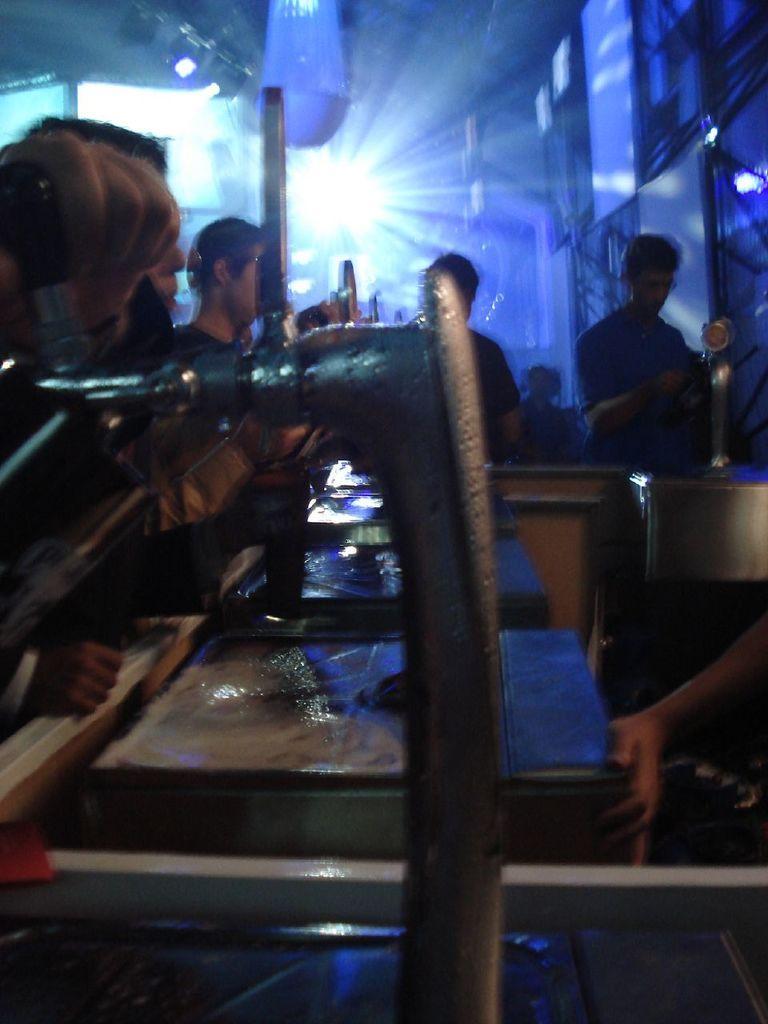Describe this image in one or two sentences. In this picture we can see people standing in a place with blue lights in the background. 